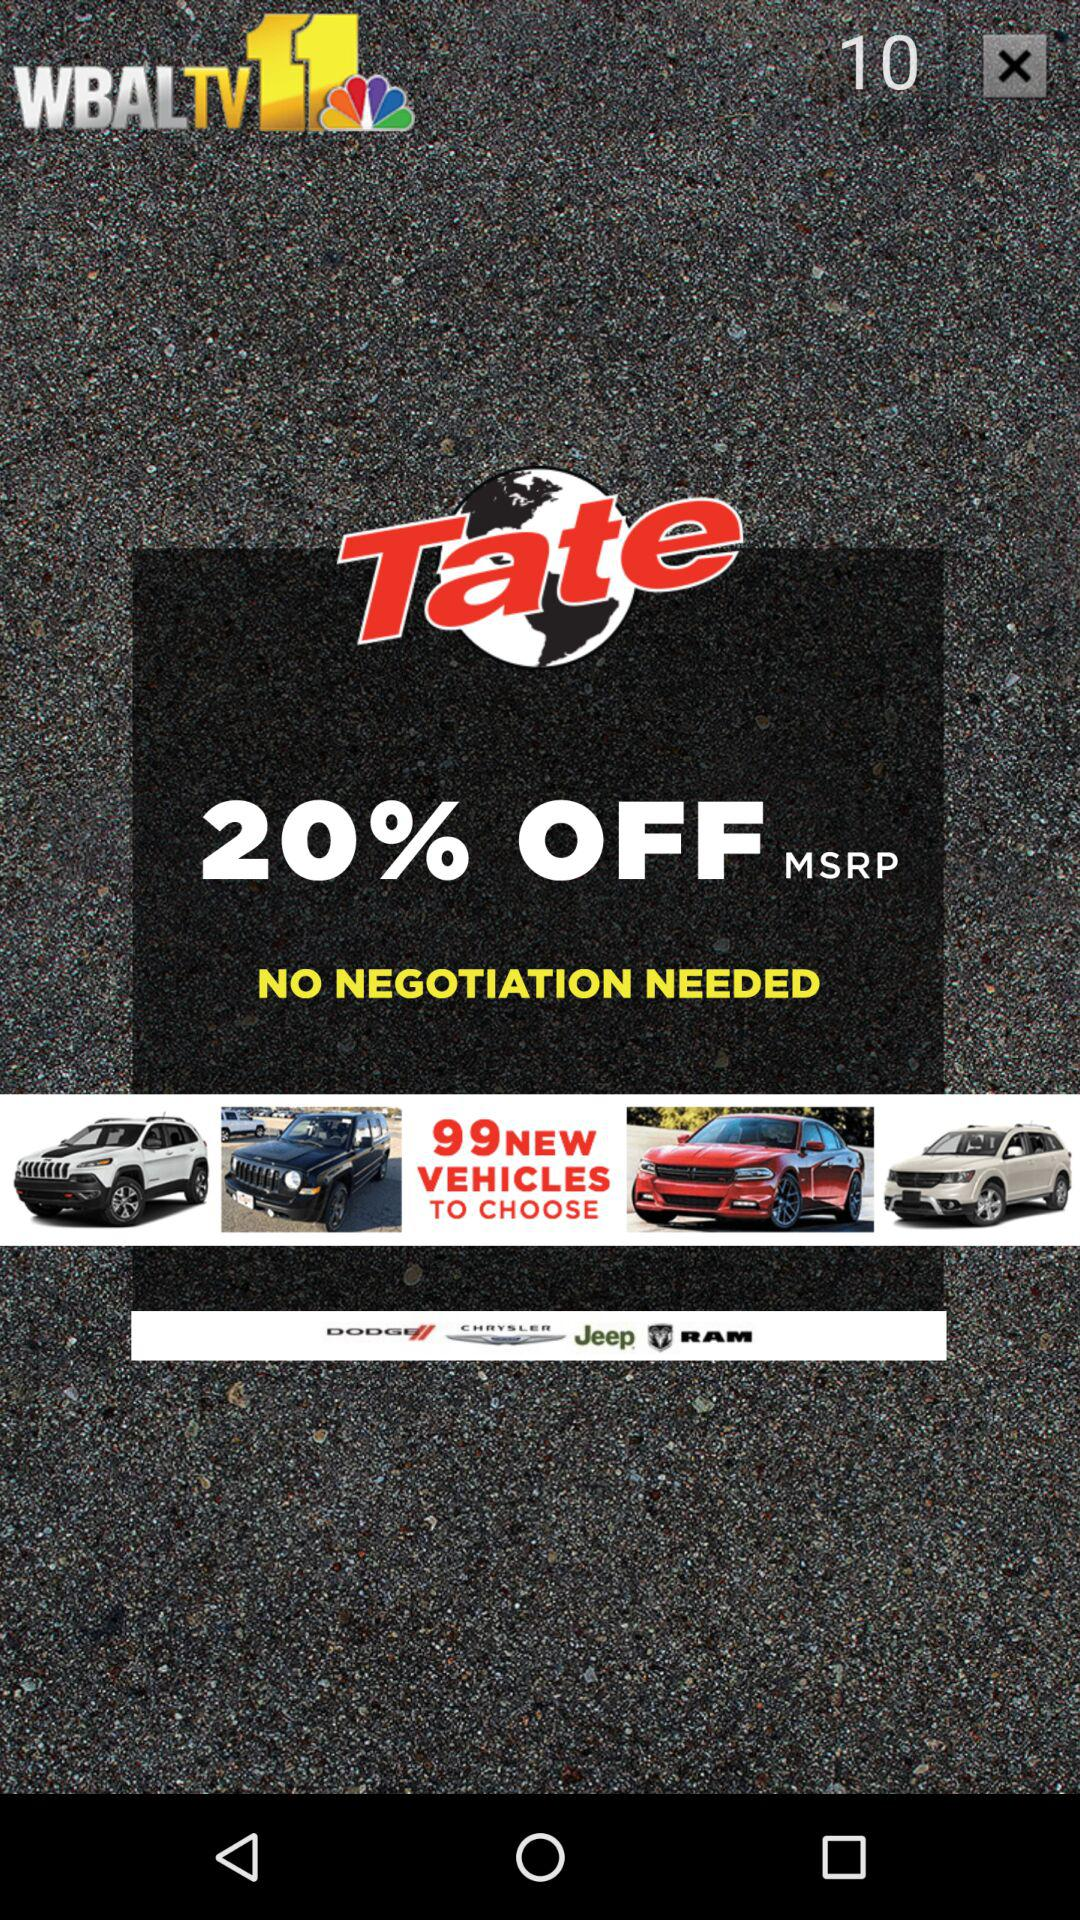What is the name of the application? The name of the application is "WBALTV11". 